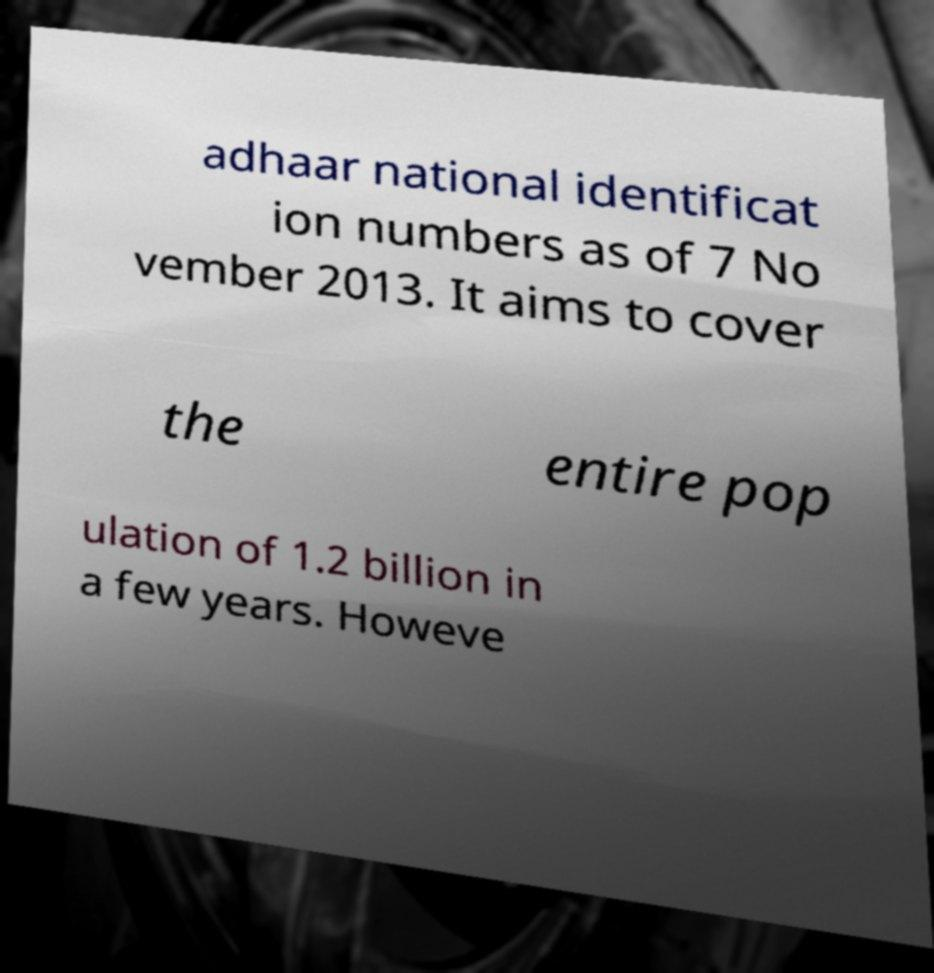What messages or text are displayed in this image? I need them in a readable, typed format. adhaar national identificat ion numbers as of 7 No vember 2013. It aims to cover the entire pop ulation of 1.2 billion in a few years. Howeve 